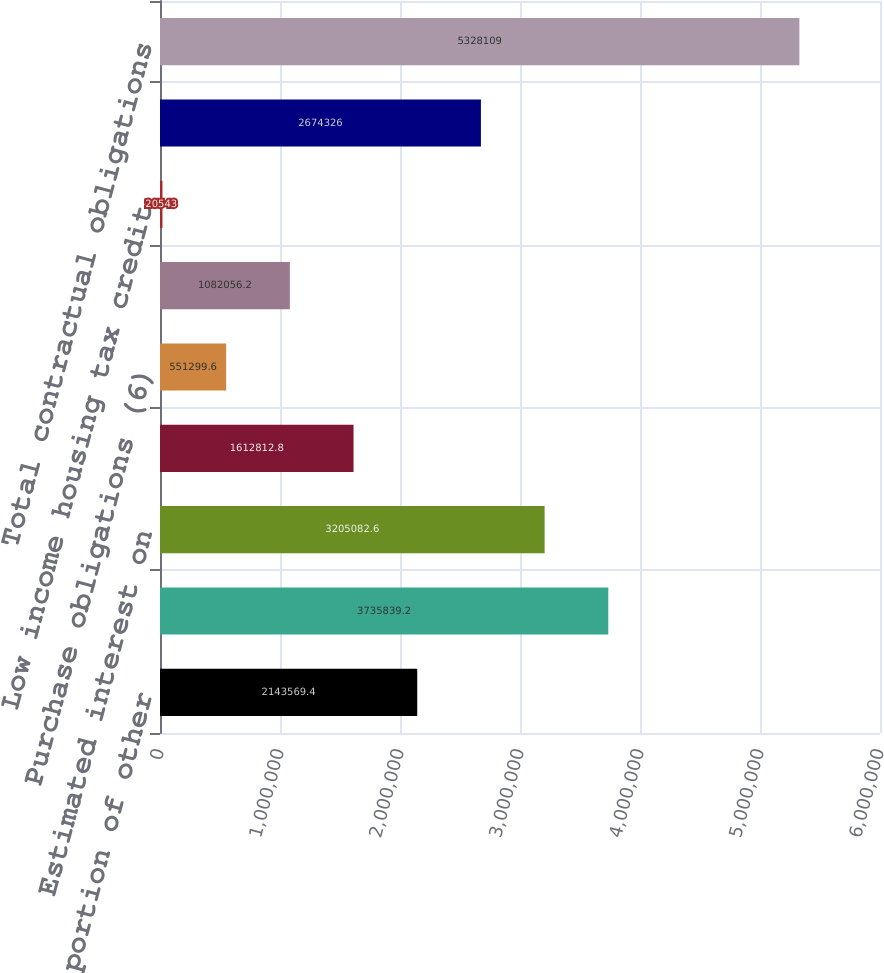Convert chart to OTSL. <chart><loc_0><loc_0><loc_500><loc_500><bar_chart><fcel>Long-term portion of other<fcel>Sub-total long-term debt<fcel>Estimated interest on<fcel>Operating lease obligations<fcel>Purchase obligations (6)<fcel>Deferred compensation programs<fcel>Low income housing tax credit<fcel>Sub-total long-term<fcel>Total contractual obligations<nl><fcel>2.14357e+06<fcel>3.73584e+06<fcel>3.20508e+06<fcel>1.61281e+06<fcel>551300<fcel>1.08206e+06<fcel>20543<fcel>2.67433e+06<fcel>5.32811e+06<nl></chart> 